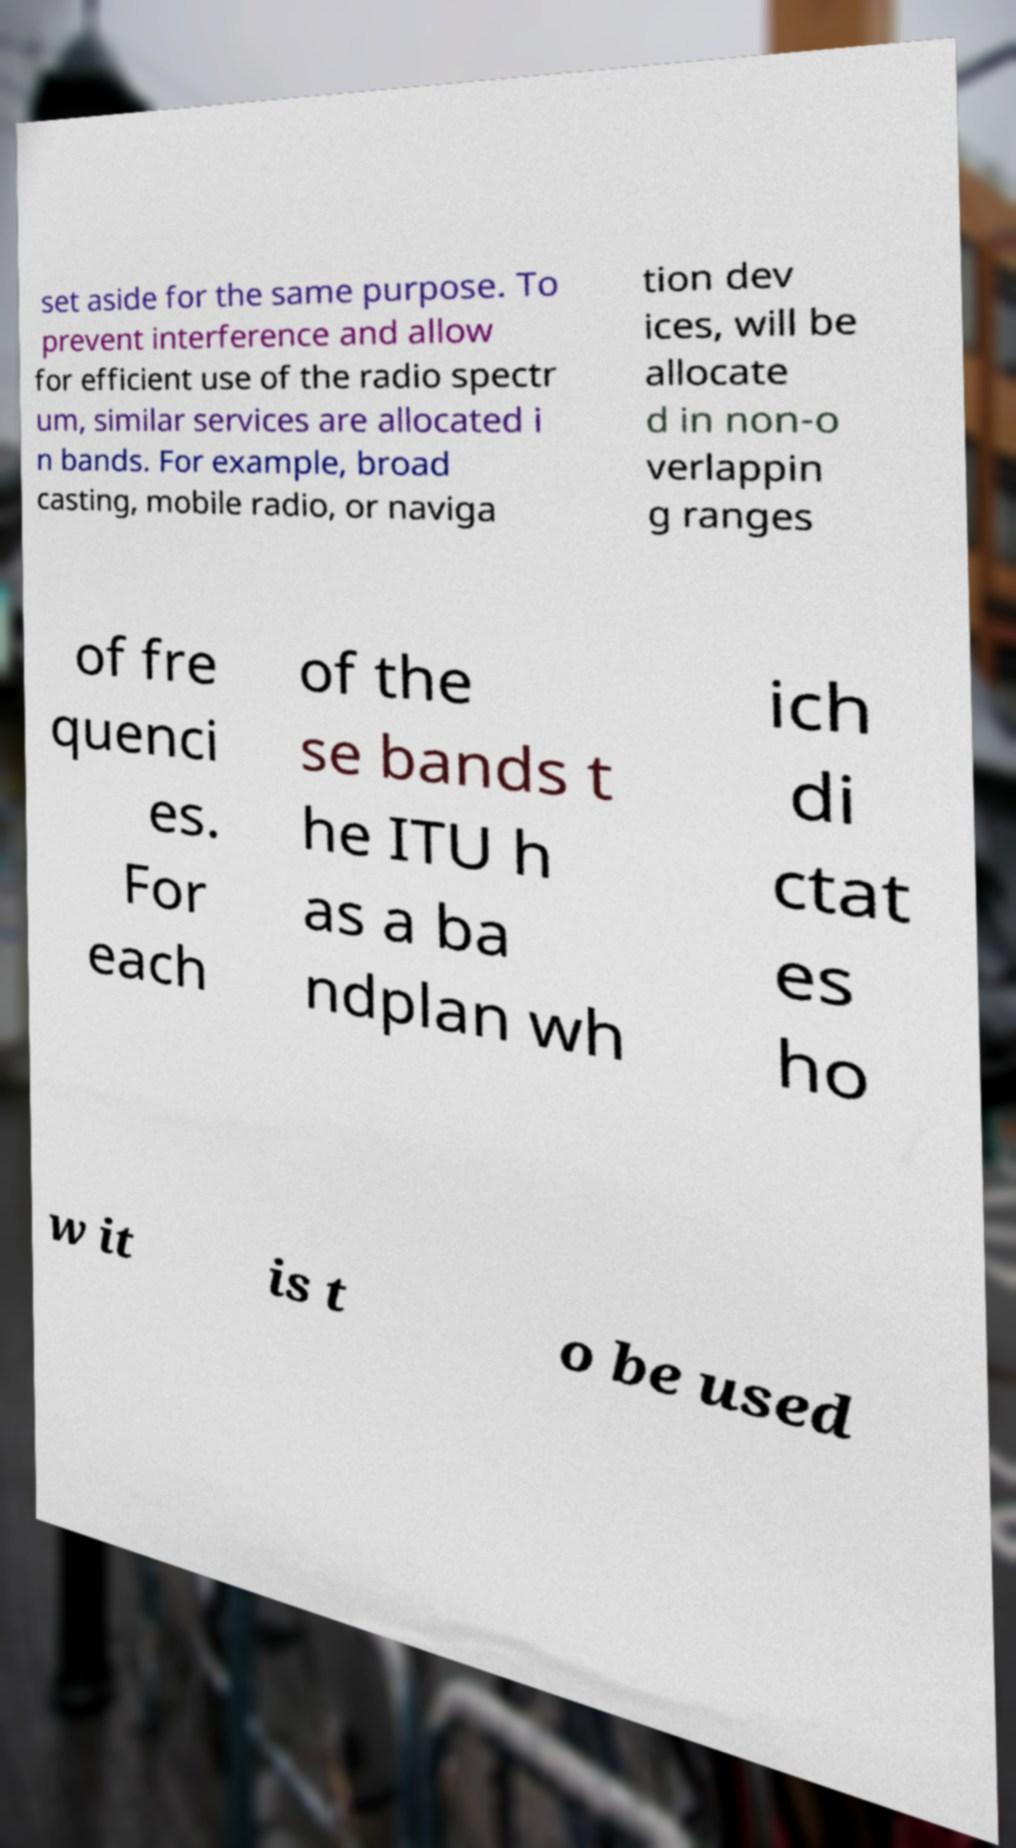Please identify and transcribe the text found in this image. set aside for the same purpose. To prevent interference and allow for efficient use of the radio spectr um, similar services are allocated i n bands. For example, broad casting, mobile radio, or naviga tion dev ices, will be allocate d in non-o verlappin g ranges of fre quenci es. For each of the se bands t he ITU h as a ba ndplan wh ich di ctat es ho w it is t o be used 